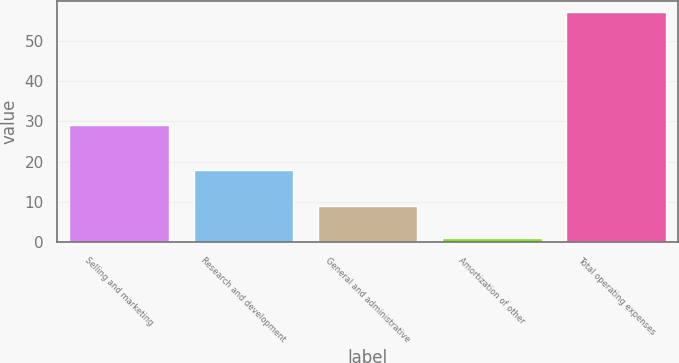Convert chart. <chart><loc_0><loc_0><loc_500><loc_500><bar_chart><fcel>Selling and marketing<fcel>Research and development<fcel>General and administrative<fcel>Amortization of other<fcel>Total operating expenses<nl><fcel>29<fcel>18<fcel>9<fcel>1<fcel>57<nl></chart> 